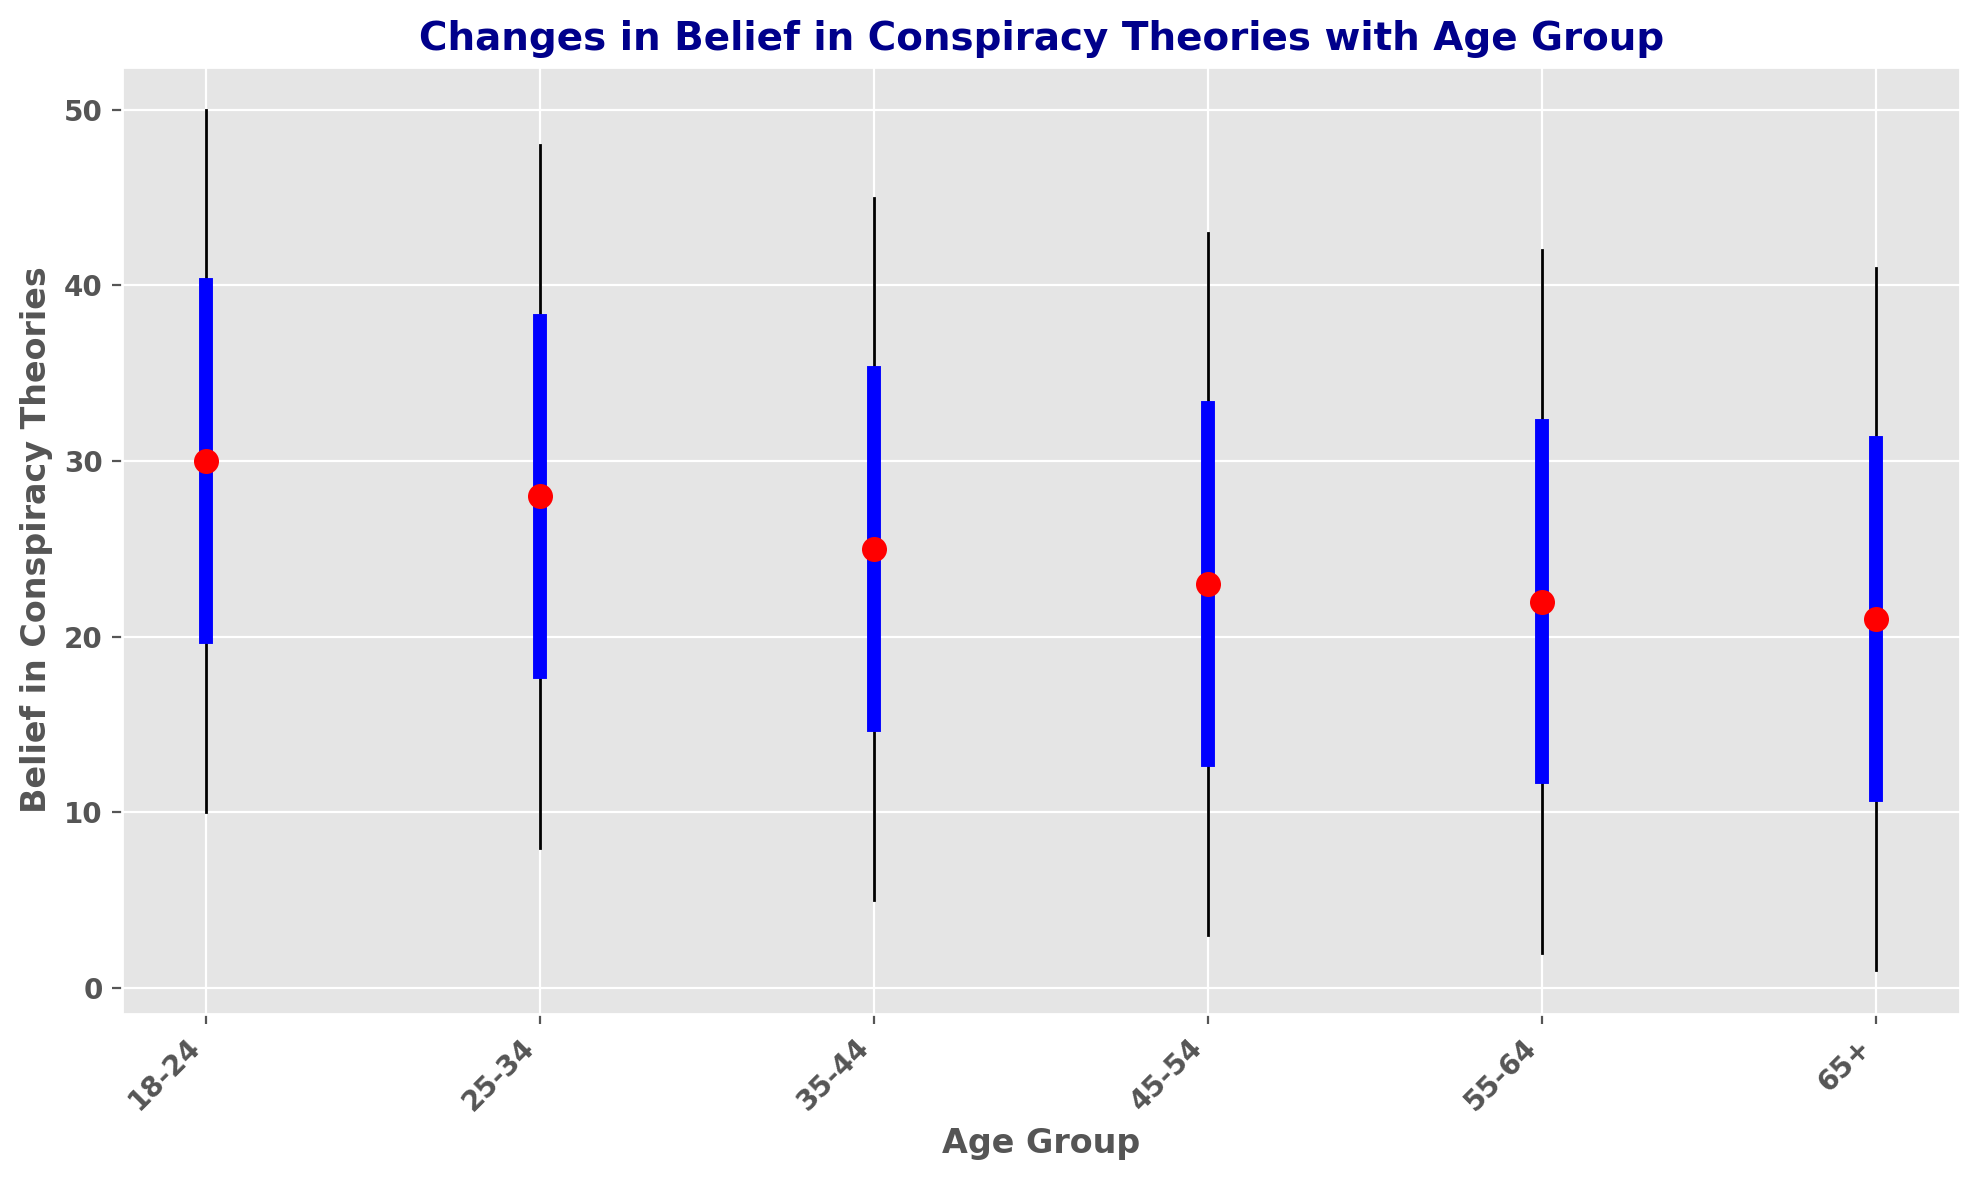What's the median belief in conspiracy theories for the age group 25-34? Locate the age group '25-34' on the x-axis. The median is indicated by a red dot in each group. The red dot for '25-34' is at the value 28.
Answer: 28 How does the range of belief in conspiracy theories change as age increases? To find the range for each age group, look at the difference between the minimum and maximum values. As age increases from '18-24' to '65+', the range tends to decrease. For '18-24', the range is 50-10=40 while for '65+', the range is 41-1=40.
Answer: Decreases Which age group has the lowest maximum belief in conspiracy theories? Identify the age group with the lowest maximum value among all plotted groups. The age group '65+' has the lowest maximum value at 41.
Answer: 65+ What is the difference in the third quartile belief in conspiracy theories between the age groups 18-24 and 45-54? The third quartile value for '18-24' is 40, and for '45-54', it is 33. The difference is 40 - 33 = 7.
Answer: 7 Compare the median belief in conspiracy theories between the age groups 35-44 and 55-64. Which one is higher? The red dots indicate the median value. For '35-44', it is 25, and for '55-64', it is 22. 25 is higher than 22.
Answer: 35-44 What is the interquartile range (IQR) of belief in conspiracy theories for the age group 18-24? The IQR is calculated by subtracting the first quartile value from the third quartile value. For '18-24', IQR = 40 - 20 = 20.
Answer: 20 Which age group shows the most consistent (least variation) belief in conspiracy theories? Consistency can be inferred from the length of the line and the width of the blue boxplot. The age group '65+' shows the most consistent belief in conspiracy theories, with the smallest range (40) and IQR (20).
Answer: 65+ How does the minimum belief in conspiracy theories for the age group 18-24 compare to that for the age group 55-64? The minimum value in '18-24' is 10 and in '55-64' is 2. 10 is greater than 2.
Answer: 18-24 